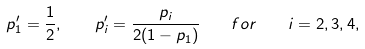<formula> <loc_0><loc_0><loc_500><loc_500>p _ { 1 } ^ { \prime } = \frac { 1 } { 2 } , \quad p _ { i } ^ { \prime } = \frac { p _ { i } } { 2 ( 1 - p _ { 1 } ) } \quad f o r \quad i = 2 , 3 , 4 ,</formula> 